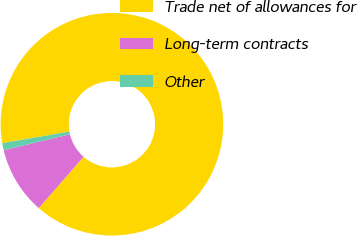<chart> <loc_0><loc_0><loc_500><loc_500><pie_chart><fcel>Trade net of allowances for<fcel>Long-term contracts<fcel>Other<nl><fcel>89.14%<fcel>9.84%<fcel>1.02%<nl></chart> 